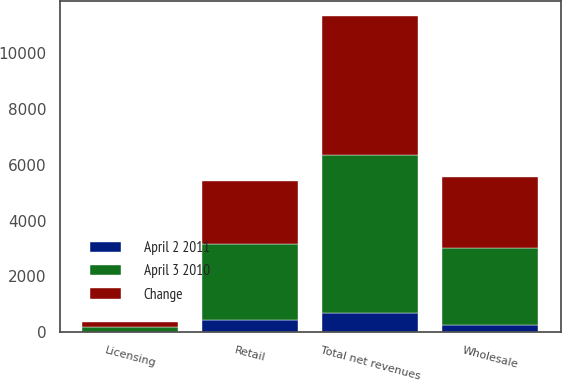<chart> <loc_0><loc_0><loc_500><loc_500><stacked_bar_chart><ecel><fcel>Wholesale<fcel>Retail<fcel>Licensing<fcel>Total net revenues<nl><fcel>April 3 2010<fcel>2777.6<fcel>2704.2<fcel>178.5<fcel>5660.3<nl><fcel>Change<fcel>2532.4<fcel>2263.1<fcel>183.4<fcel>4978.9<nl><fcel>April 2 2011<fcel>245.2<fcel>441.1<fcel>4.9<fcel>681.4<nl></chart> 